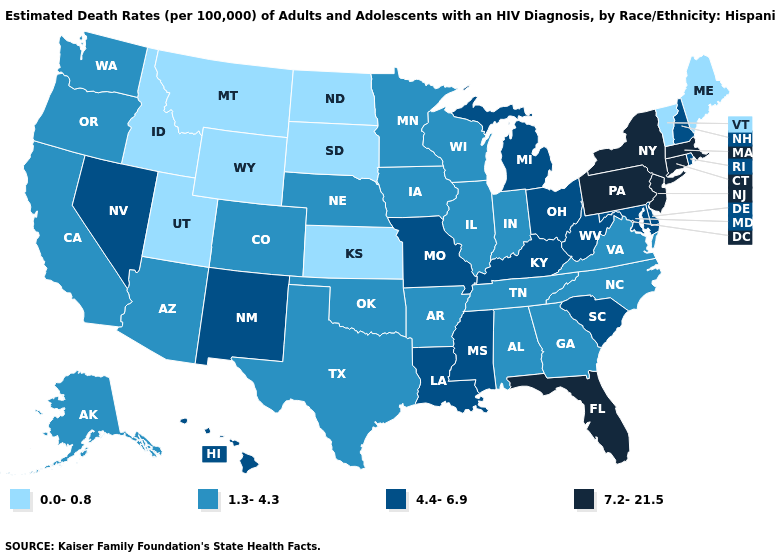Name the states that have a value in the range 4.4-6.9?
Short answer required. Delaware, Hawaii, Kentucky, Louisiana, Maryland, Michigan, Mississippi, Missouri, Nevada, New Hampshire, New Mexico, Ohio, Rhode Island, South Carolina, West Virginia. Does New Mexico have a higher value than Montana?
Quick response, please. Yes. Does North Dakota have the same value as Montana?
Answer briefly. Yes. What is the value of South Carolina?
Answer briefly. 4.4-6.9. Is the legend a continuous bar?
Short answer required. No. Does the first symbol in the legend represent the smallest category?
Be succinct. Yes. Does New Hampshire have a lower value than Massachusetts?
Quick response, please. Yes. Among the states that border Wisconsin , does Michigan have the lowest value?
Quick response, please. No. What is the value of Arkansas?
Answer briefly. 1.3-4.3. Does Maryland have a lower value than Massachusetts?
Be succinct. Yes. What is the value of Idaho?
Write a very short answer. 0.0-0.8. Does Pennsylvania have the lowest value in the Northeast?
Answer briefly. No. Which states hav the highest value in the South?
Give a very brief answer. Florida. Name the states that have a value in the range 4.4-6.9?
Give a very brief answer. Delaware, Hawaii, Kentucky, Louisiana, Maryland, Michigan, Mississippi, Missouri, Nevada, New Hampshire, New Mexico, Ohio, Rhode Island, South Carolina, West Virginia. Which states have the lowest value in the USA?
Concise answer only. Idaho, Kansas, Maine, Montana, North Dakota, South Dakota, Utah, Vermont, Wyoming. 